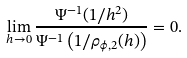<formula> <loc_0><loc_0><loc_500><loc_500>\lim _ { h \to 0 } \frac { \Psi ^ { - 1 } ( 1 / h ^ { 2 } ) } { \Psi ^ { - 1 } \left ( 1 / \rho _ { \phi , 2 } ( h ) \right ) } = 0 .</formula> 